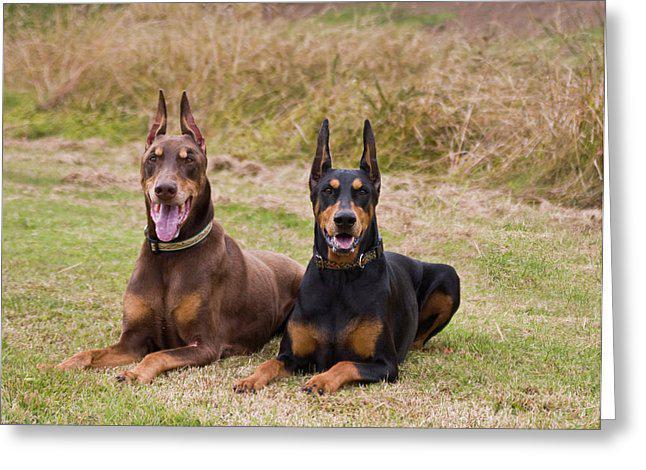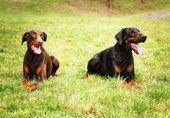The first image is the image on the left, the second image is the image on the right. Analyze the images presented: Is the assertion "The left image includes side-by-side, identically-posed, forward-facing dobermans with erect pointy ears, and the right image contains two dobermans with floppy ears." valid? Answer yes or no. Yes. The first image is the image on the left, the second image is the image on the right. Given the left and right images, does the statement "A darker colored dog is lying next to a lighter colored one of the same breed in at least one image." hold true? Answer yes or no. Yes. 